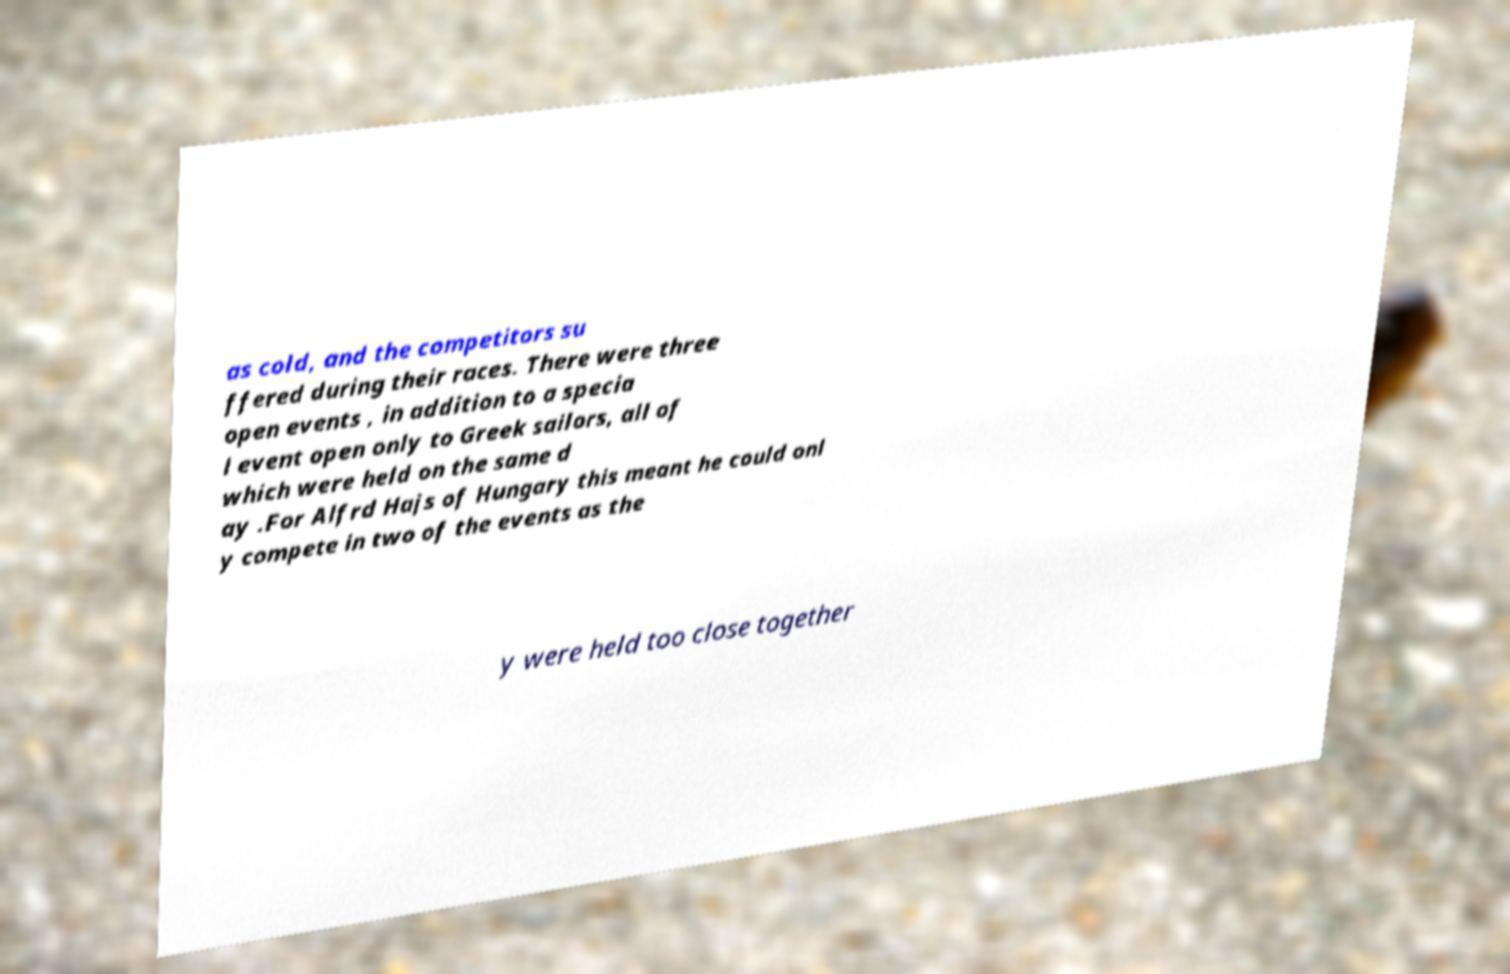For documentation purposes, I need the text within this image transcribed. Could you provide that? as cold, and the competitors su ffered during their races. There were three open events , in addition to a specia l event open only to Greek sailors, all of which were held on the same d ay .For Alfrd Hajs of Hungary this meant he could onl y compete in two of the events as the y were held too close together 